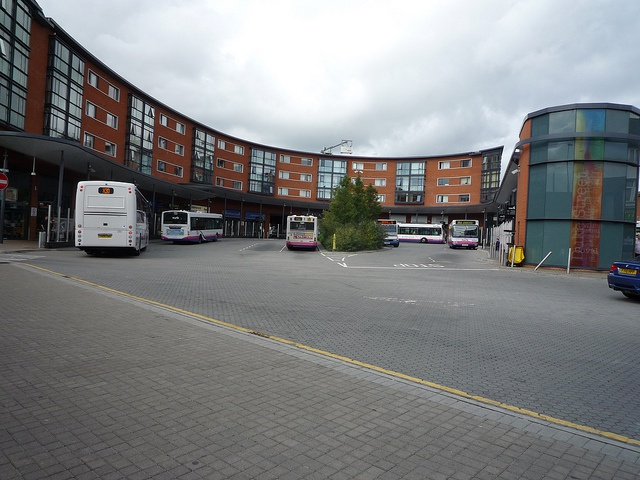Describe the objects in this image and their specific colors. I can see bus in black, darkgray, gray, and lightgray tones, bus in purple, black, darkgray, and gray tones, car in black, navy, gray, and darkblue tones, bus in black, darkgray, gray, and brown tones, and bus in black, lightgray, gray, and darkgray tones in this image. 